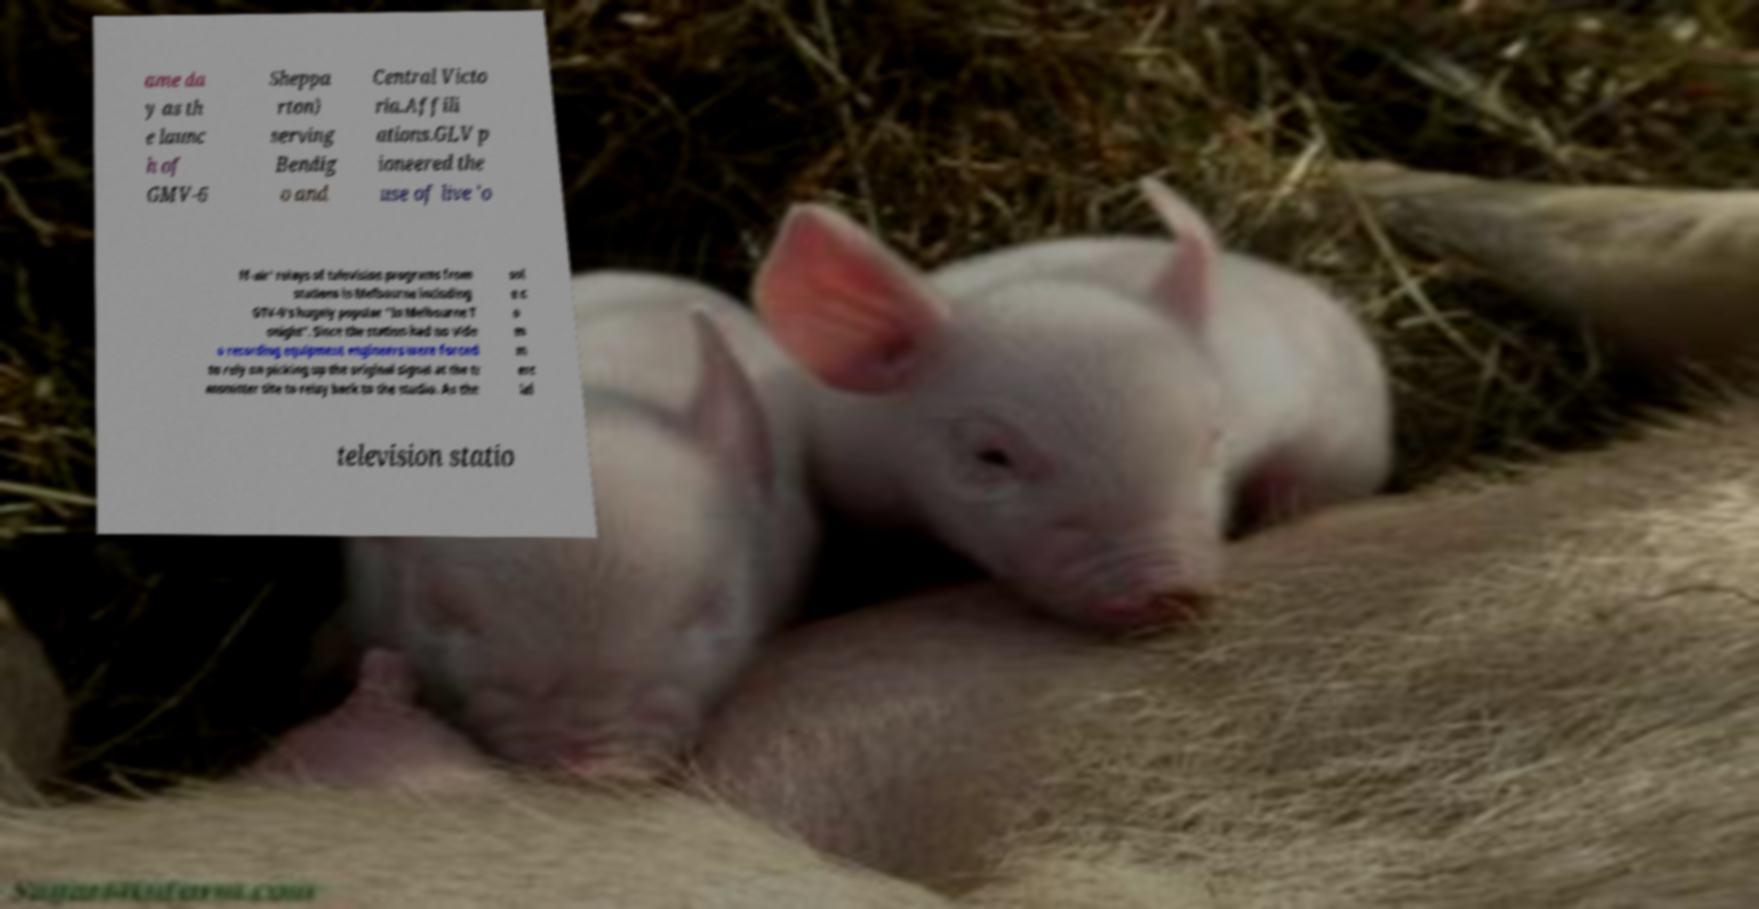Could you assist in decoding the text presented in this image and type it out clearly? ame da y as th e launc h of GMV-6 Sheppa rton) serving Bendig o and Central Victo ria.Affili ations.GLV p ioneered the use of live 'o ff-air' relays of television programs from stations in Melbourne including GTV-9's hugely popular "In Melbourne T onight". Since the station had no vide o recording equipment engineers were forced to rely on picking up the original signal at the tr ansmitter site to relay back to the studio. As the sol e c o m m erc ial television statio 